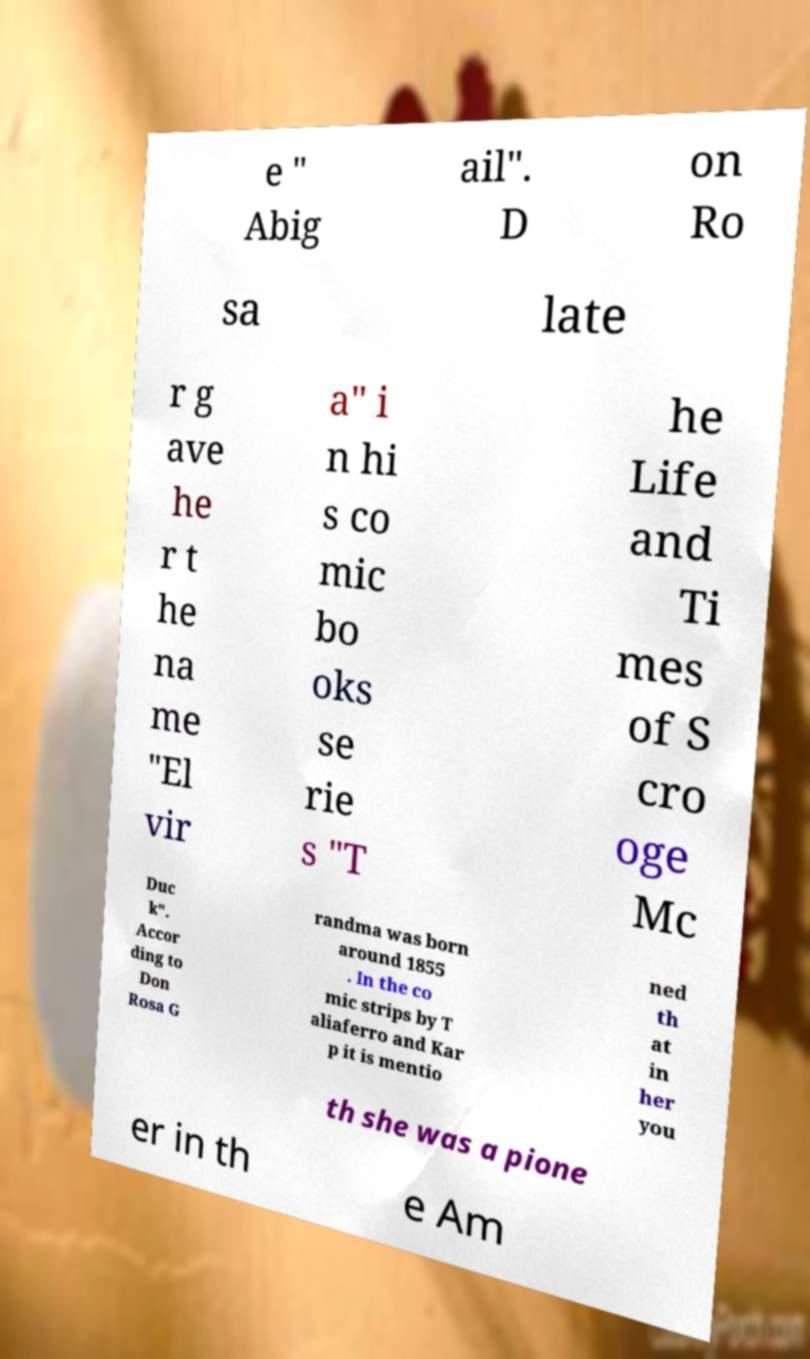What messages or text are displayed in this image? I need them in a readable, typed format. e " Abig ail". D on Ro sa late r g ave he r t he na me "El vir a" i n hi s co mic bo oks se rie s "T he Life and Ti mes of S cro oge Mc Duc k". Accor ding to Don Rosa G randma was born around 1855 . In the co mic strips by T aliaferro and Kar p it is mentio ned th at in her you th she was a pione er in th e Am 